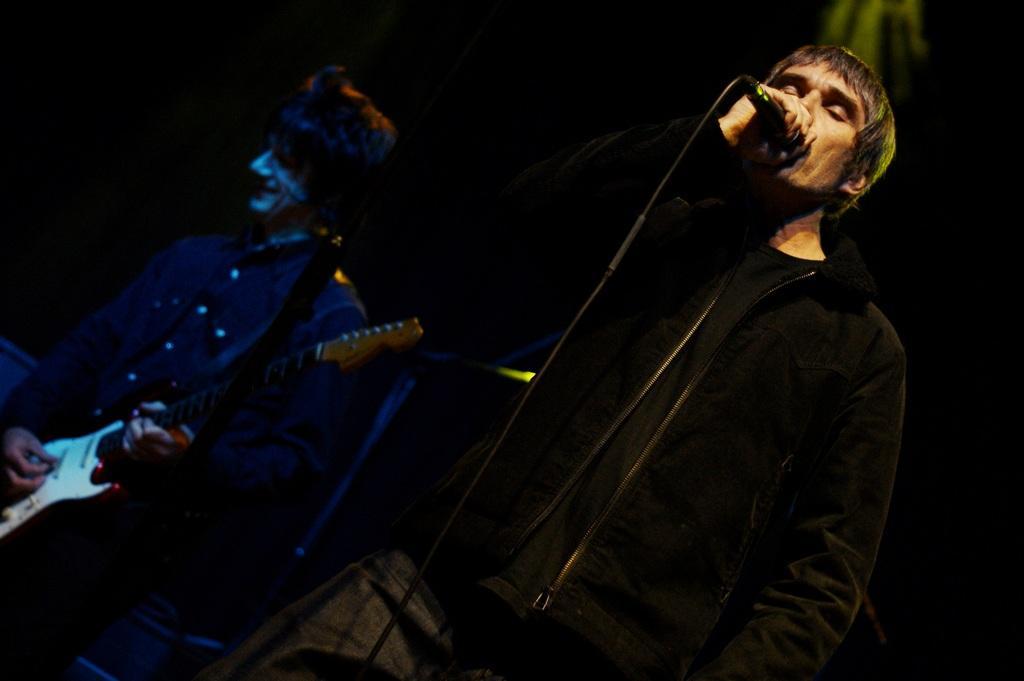Please provide a concise description of this image. In this image, in the right side there is a man standing and holding a microphone which is in black color, he is singing in the microphone, in the left side there is a man standing and holding a music instrument which is in white color. 